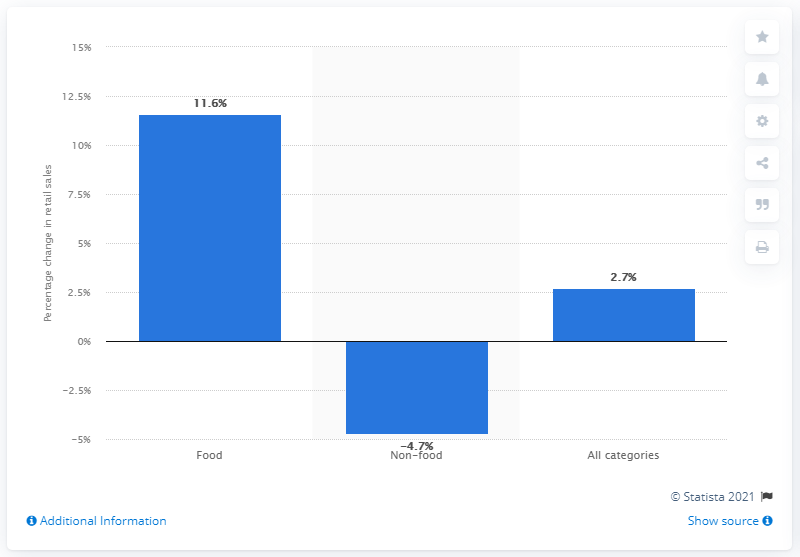Draw attention to some important aspects in this diagram. During April 2021, food retail sales showed an increase of 11.6%. 